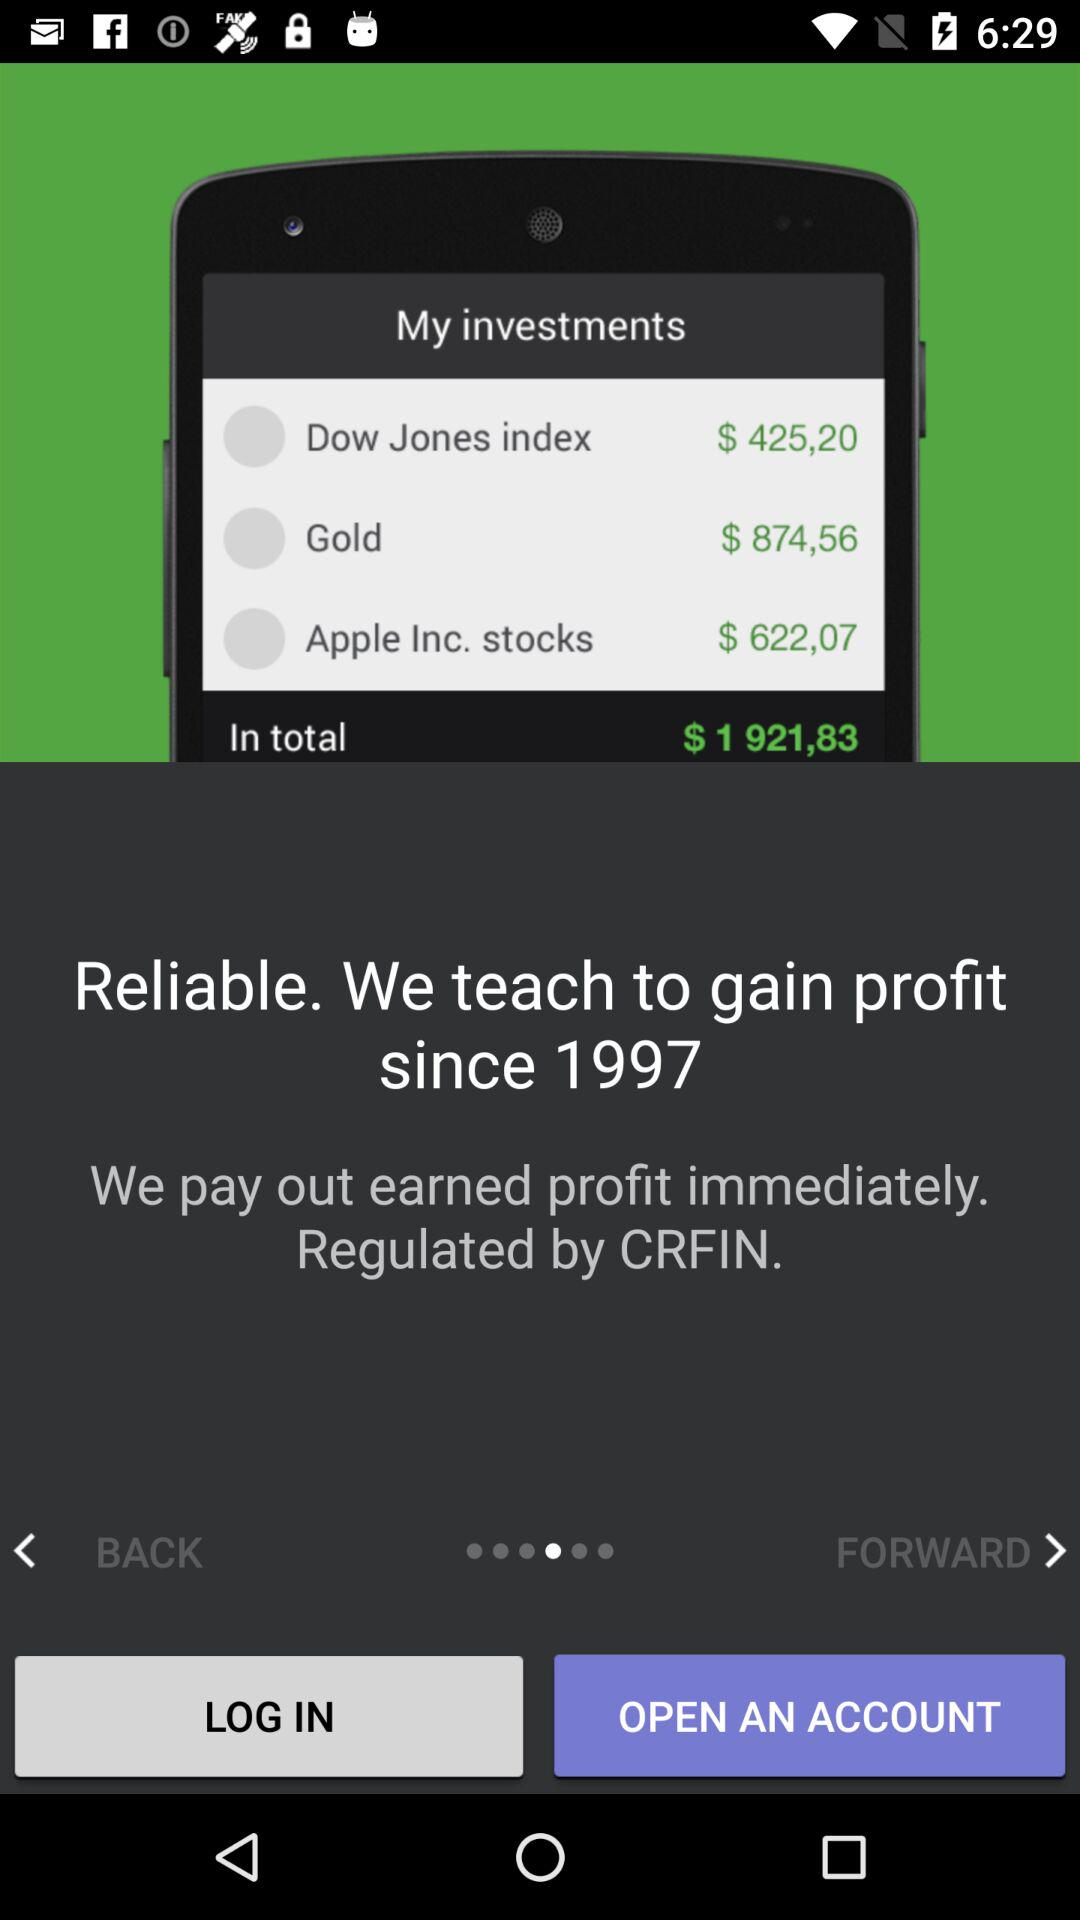By whom has it been regulated? It is regulated by the CRFIN. 